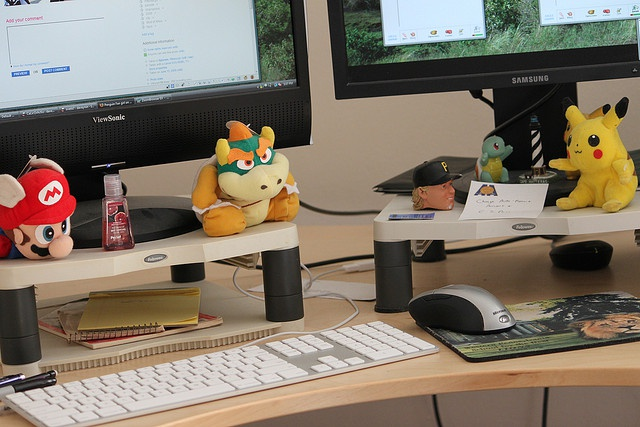Describe the objects in this image and their specific colors. I can see tv in lightblue, black, lightgray, and gray tones, tv in lightblue, black, and teal tones, keyboard in lightblue, lightgray, and darkgray tones, book in lightblue, olive, and maroon tones, and mouse in lightblue, black, darkgray, gray, and maroon tones in this image. 